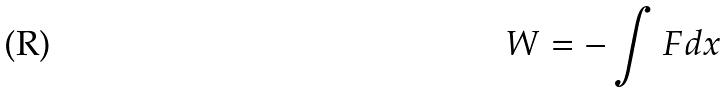Convert formula to latex. <formula><loc_0><loc_0><loc_500><loc_500>W = - \int F d x</formula> 